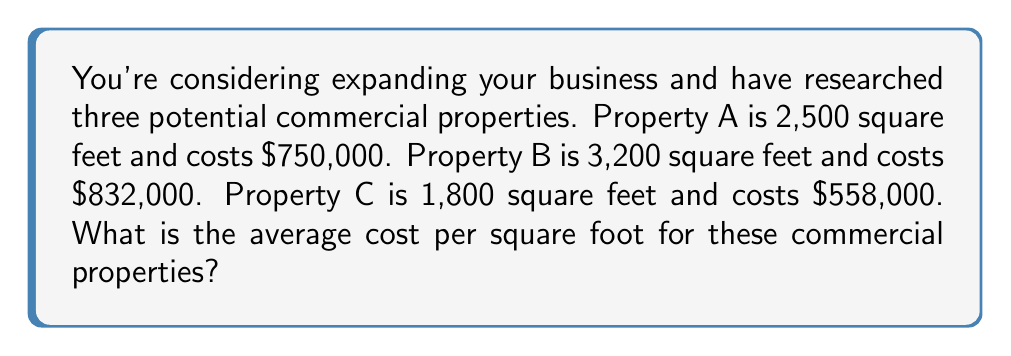Solve this math problem. To solve this problem, we'll follow these steps:

1. Calculate the cost per square foot for each property:

   Property A: $\frac{\$750,000}{2,500 \text{ sq ft}} = \$300 \text{ per sq ft}$
   Property B: $\frac{\$832,000}{3,200 \text{ sq ft}} = \$260 \text{ per sq ft}$
   Property C: $\frac{\$558,000}{1,800 \text{ sq ft}} = \$310 \text{ per sq ft}$

2. Add up the costs per square foot:
   $\$300 + \$260 + \$310 = \$870$

3. Divide the sum by the number of properties (3) to get the average:
   $\frac{\$870}{3} = \$290 \text{ per sq ft}$

Therefore, the average cost per square foot for these commercial properties is $290.
Answer: $290 per square foot 